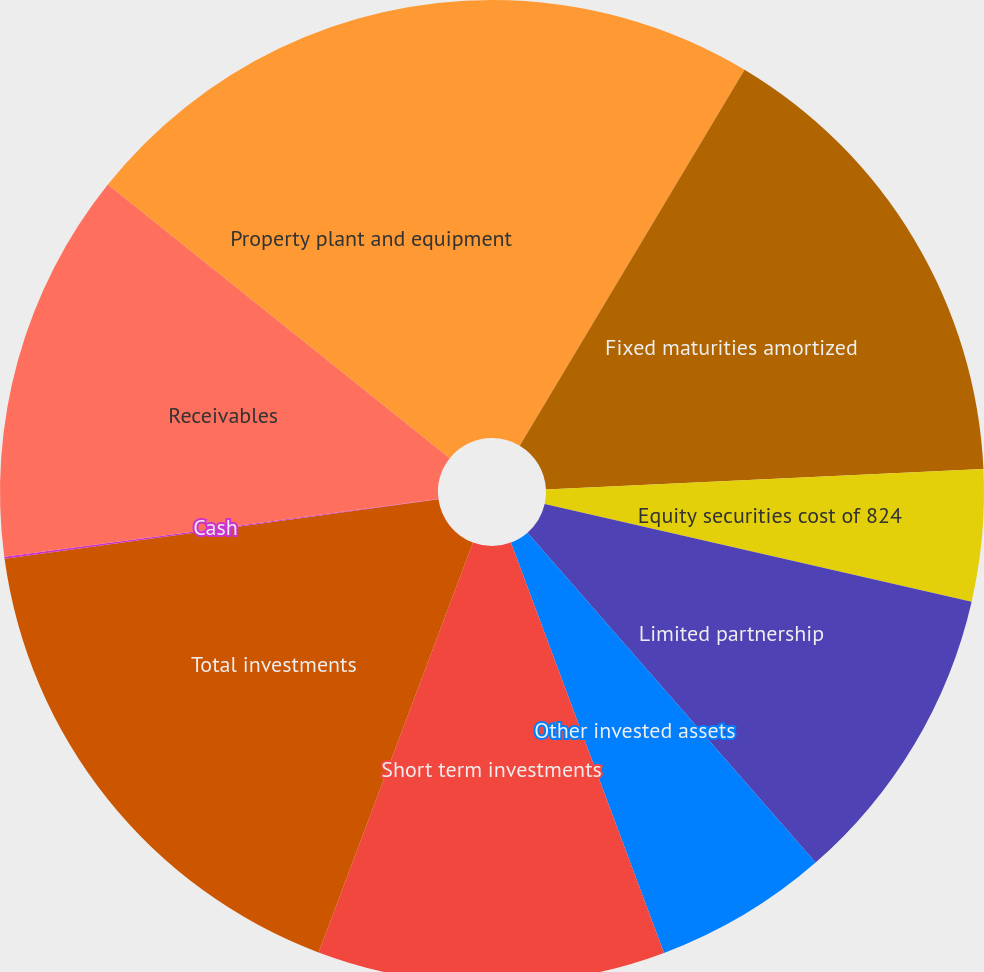Convert chart to OTSL. <chart><loc_0><loc_0><loc_500><loc_500><pie_chart><fcel>December 31 (Dollar amounts in<fcel>Fixed maturities amortized<fcel>Equity securities cost of 824<fcel>Limited partnership<fcel>Other invested assets<fcel>Short term investments<fcel>Total investments<fcel>Cash<fcel>Receivables<fcel>Property plant and equipment<nl><fcel>8.58%<fcel>15.68%<fcel>4.32%<fcel>10.0%<fcel>5.74%<fcel>11.42%<fcel>17.1%<fcel>0.07%<fcel>12.84%<fcel>14.26%<nl></chart> 